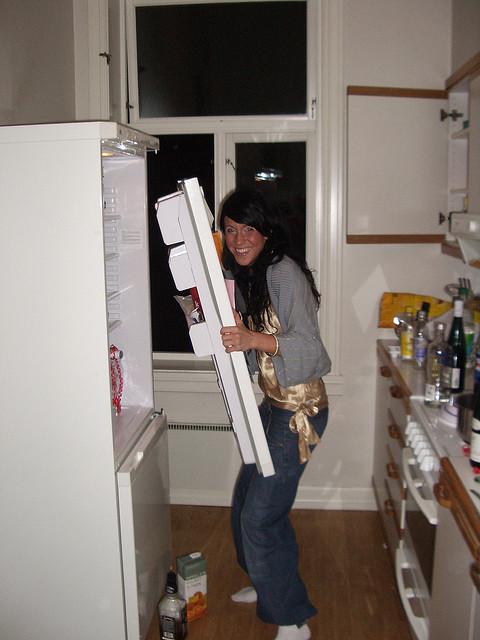Could this be a practice session?
Concise answer only. No. What is this person holding?
Short answer required. Fridge door. Is this woman happy?
Keep it brief. Yes. Is this lady breaking the fridge?
Short answer required. Yes. Is the fridge new?
Answer briefly. No. Is this woman having a party?
Short answer required. No. 